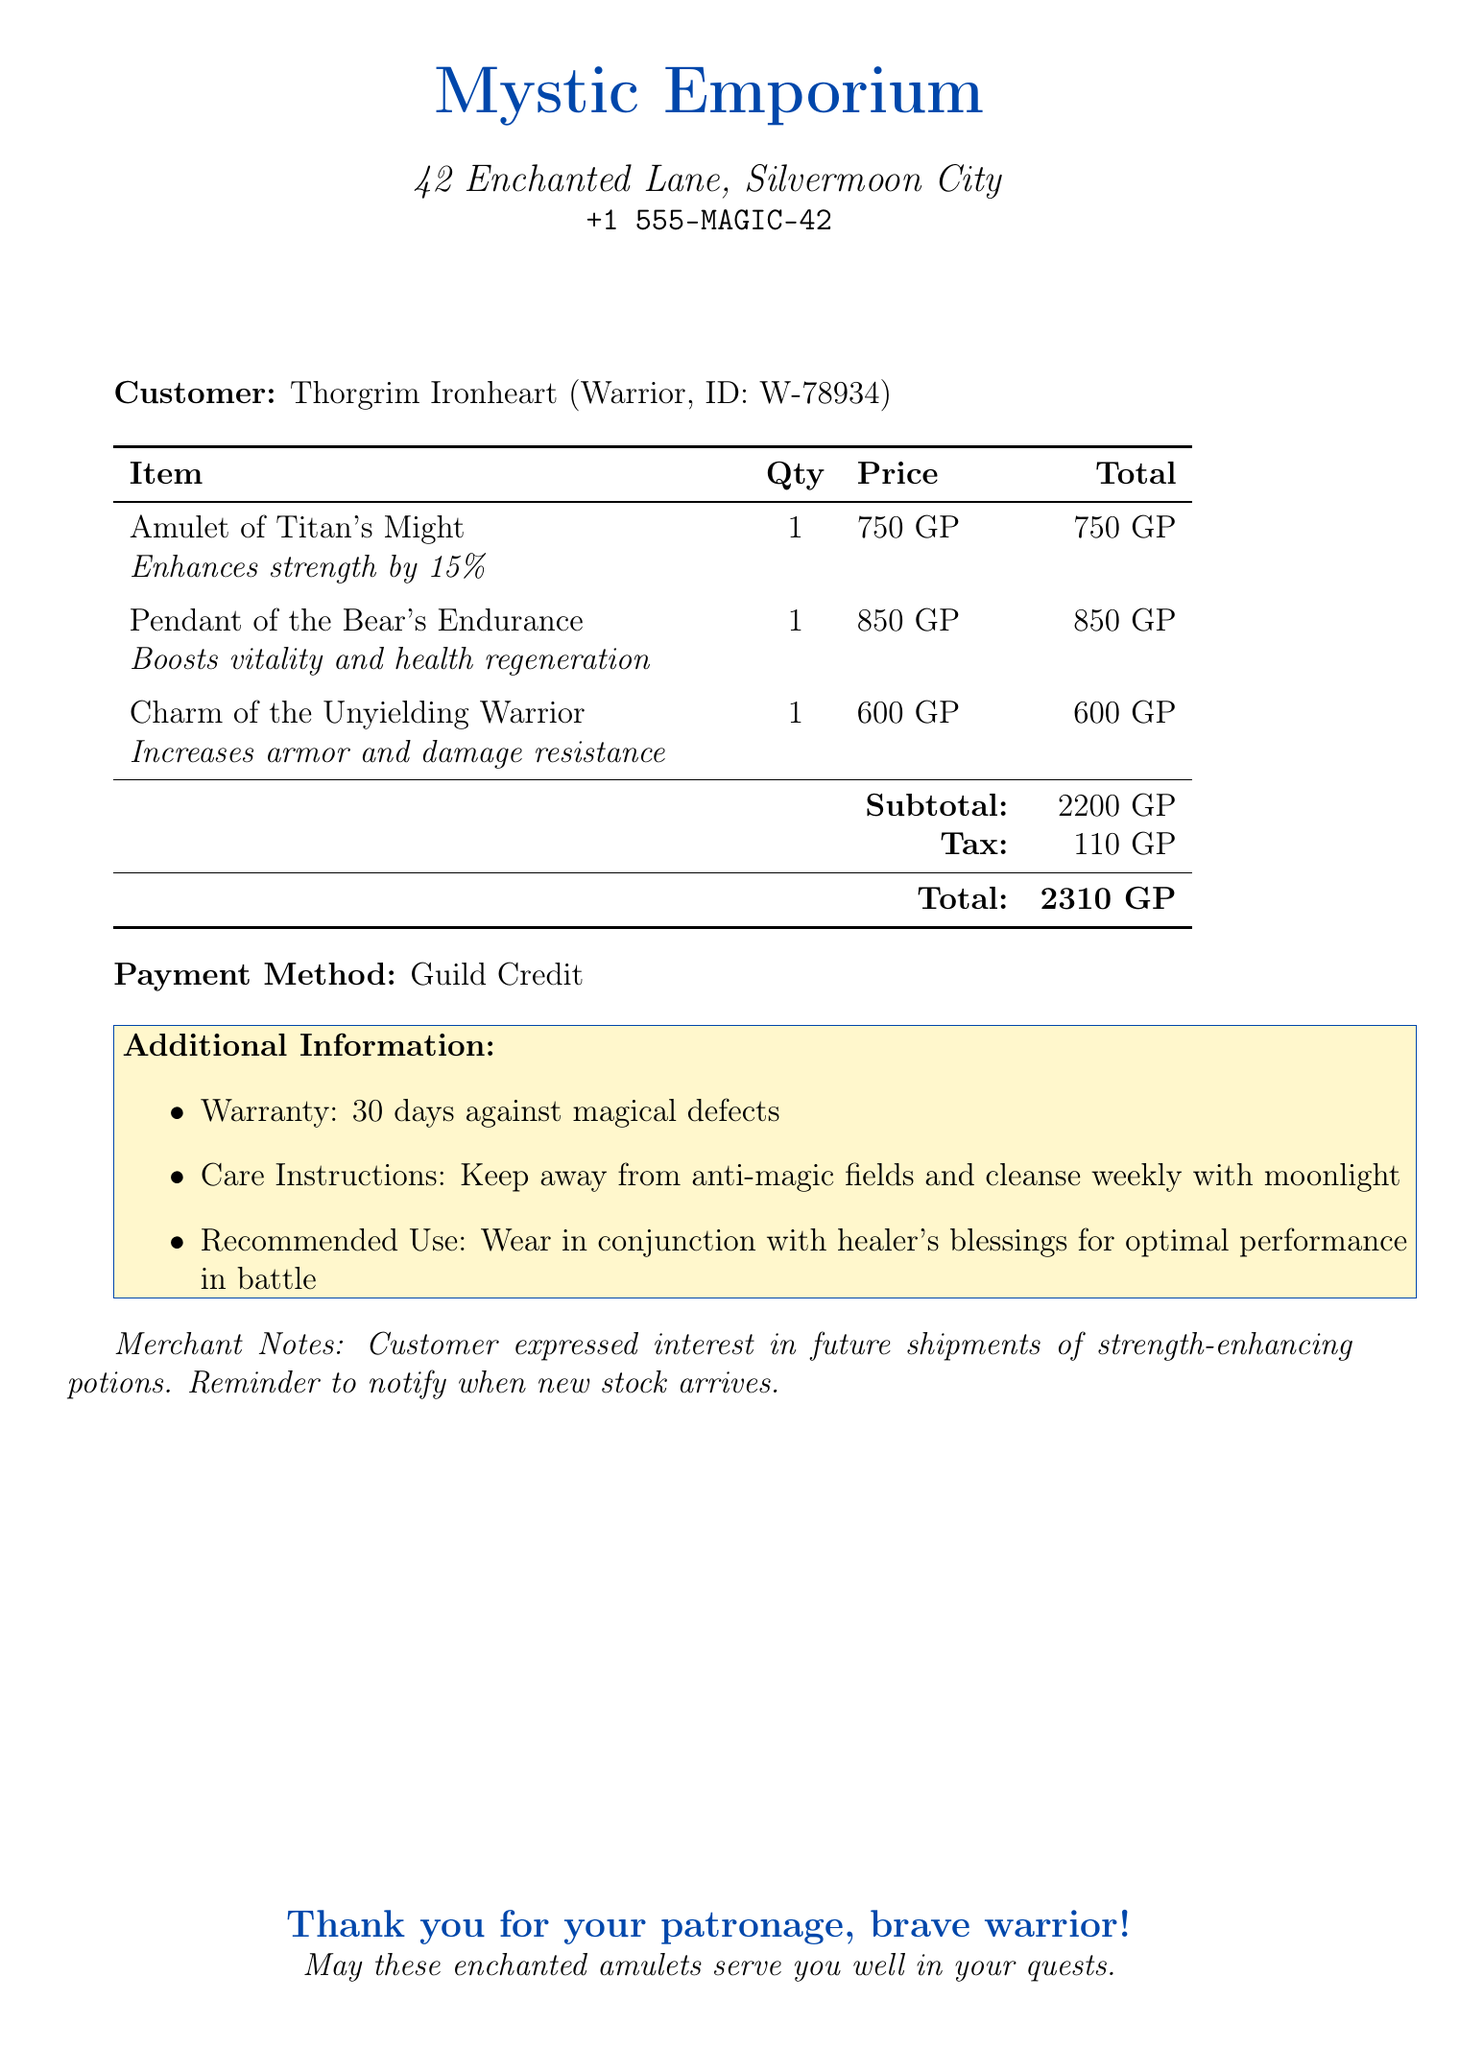What is the name of the merchant? The document lists the merchant's name as Mystic Emporium.
Answer: Mystic Emporium What is the total amount paid for the items? The total amount paid is clearly stated at the bottom of the payment section of the document.
Answer: 2310 Gold Pieces On what date was the transaction made? The date of the transaction is noted prominently in the document.
Answer: 15th day of the Harvest Moon, Year 1242 How many items were purchased in total? The document lists three items purchased, indicating the total count of items bought.
Answer: 3 What is the warranty period for the purchased items? The warranty information is specifically mentioned in the additional information section of the document.
Answer: 30 days against magical defects What method was used to pay for the transaction? The payment method is clearly indicated in the payment section of the document.
Answer: Guild Credit What item enhances strength? The document describes the "Amulet of Titan's Might" as the item that enhances strength by 15%.
Answer: Amulet of Titan's Might What care instructions are provided for the amulets? Care instructions are provided in the additional information section regarding maintenance of the amulets.
Answer: Keep away from anti-magic fields and cleanse weekly with moonlight 